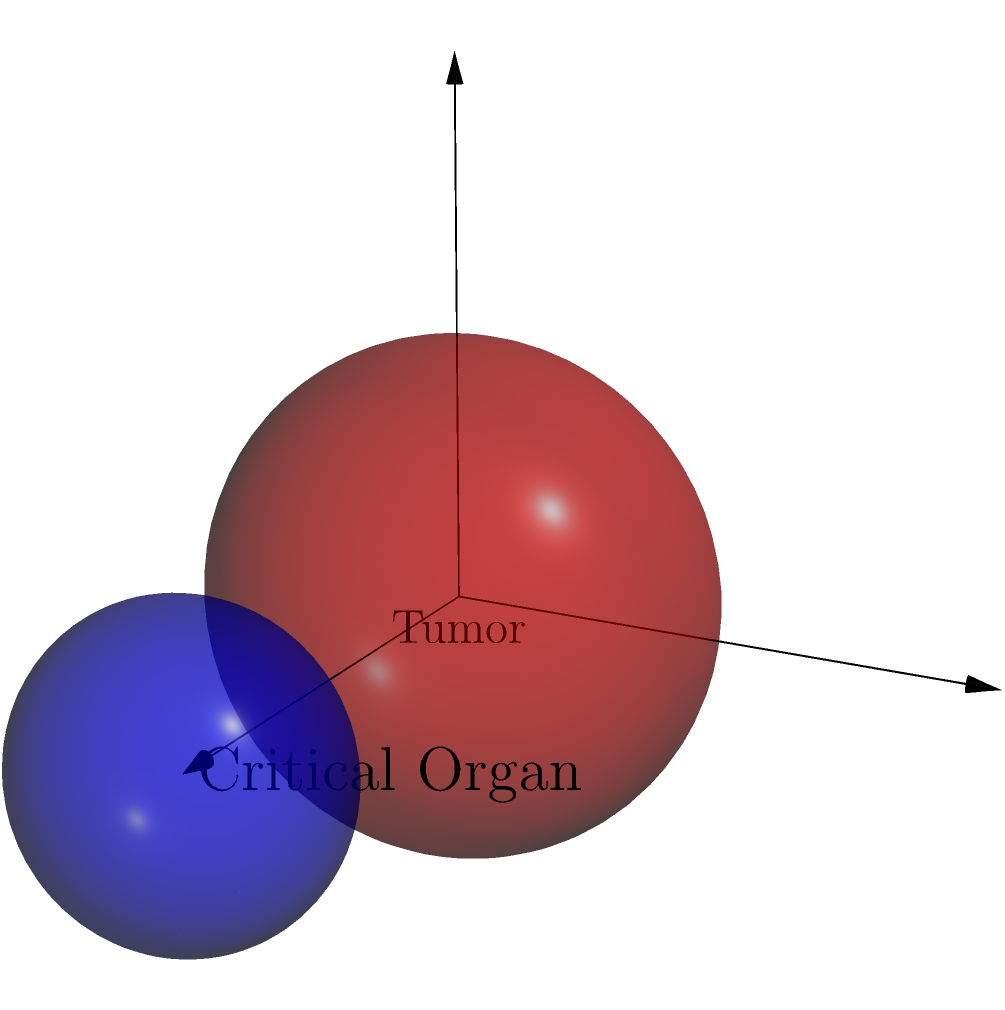A spherical tumor with a radius of 1.5 cm is located at the origin of a 3D coordinate system. A critical organ, represented by a sphere with a radius of 0.8 cm, is centered at coordinates (3, 0, 0). The angle $\theta$ between the positive z-axis and the line connecting the centers of the tumor and the critical organ is measured. What is the value of $\theta$ in degrees? To solve this problem, we need to follow these steps:

1) The tumor is at (0, 0, 0) and the critical organ is at (3, 0, 0).

2) The line connecting their centers forms the hypotenuse of a right-angled triangle in the xz-plane.

3) We can use the arctangent function to find the angle:

   $\theta = \arctan(\frac{\text{opposite}}{\text{adjacent}})$

4) The opposite side is the z-coordinate difference (0), and the adjacent side is the x-coordinate difference (3).

5) Therefore:

   $\theta = \arctan(\frac{0}{3}) = 0$

6) However, the question states that $\theta$ is measured from the positive z-axis, not the x-axis.

7) The angle we calculated is complementary to the angle we need. So:

   $\theta = 90° - 0° = 90°$

Thus, the angle $\theta$ between the positive z-axis and the line connecting the centers of the tumor and the critical organ is 90°.
Answer: 90° 